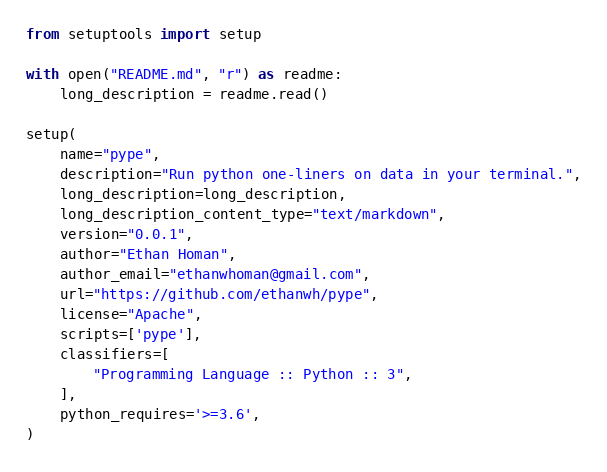<code> <loc_0><loc_0><loc_500><loc_500><_Python_>from setuptools import setup

with open("README.md", "r") as readme:
    long_description = readme.read()

setup(
    name="pype",
    description="Run python one-liners on data in your terminal.",
    long_description=long_description,
    long_description_content_type="text/markdown",
    version="0.0.1",
    author="Ethan Homan",
    author_email="ethanwhoman@gmail.com",
    url="https://github.com/ethanwh/pype",
    license="Apache",
    scripts=['pype'],
    classifiers=[
        "Programming Language :: Python :: 3",
    ],
    python_requires='>=3.6',
)
</code> 